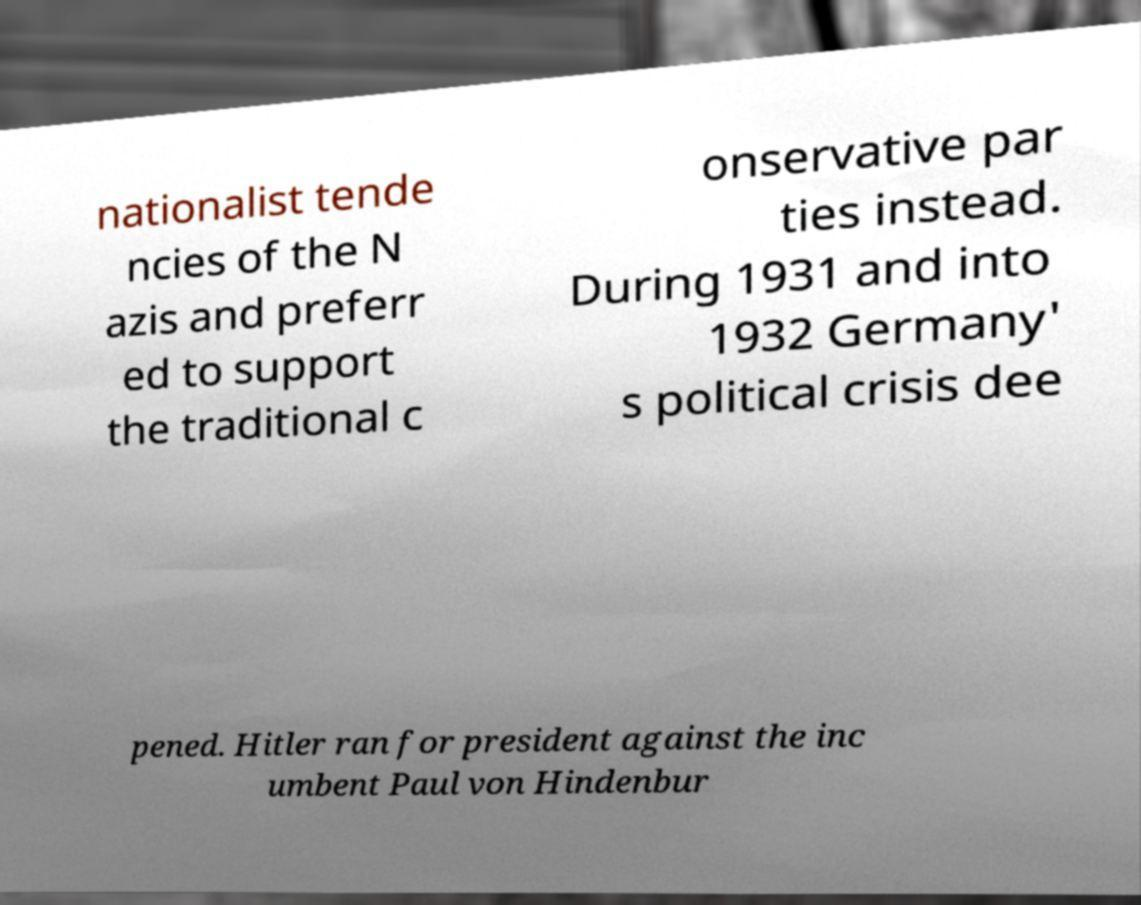Please read and relay the text visible in this image. What does it say? nationalist tende ncies of the N azis and preferr ed to support the traditional c onservative par ties instead. During 1931 and into 1932 Germany' s political crisis dee pened. Hitler ran for president against the inc umbent Paul von Hindenbur 